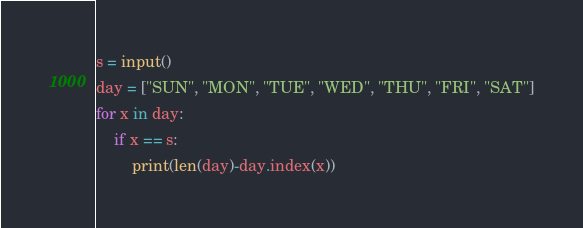<code> <loc_0><loc_0><loc_500><loc_500><_Python_>s = input()
day = ["SUN", "MON", "TUE", "WED", "THU", "FRI", "SAT"]
for x in day:
    if x == s:
        print(len(day)-day.index(x))</code> 